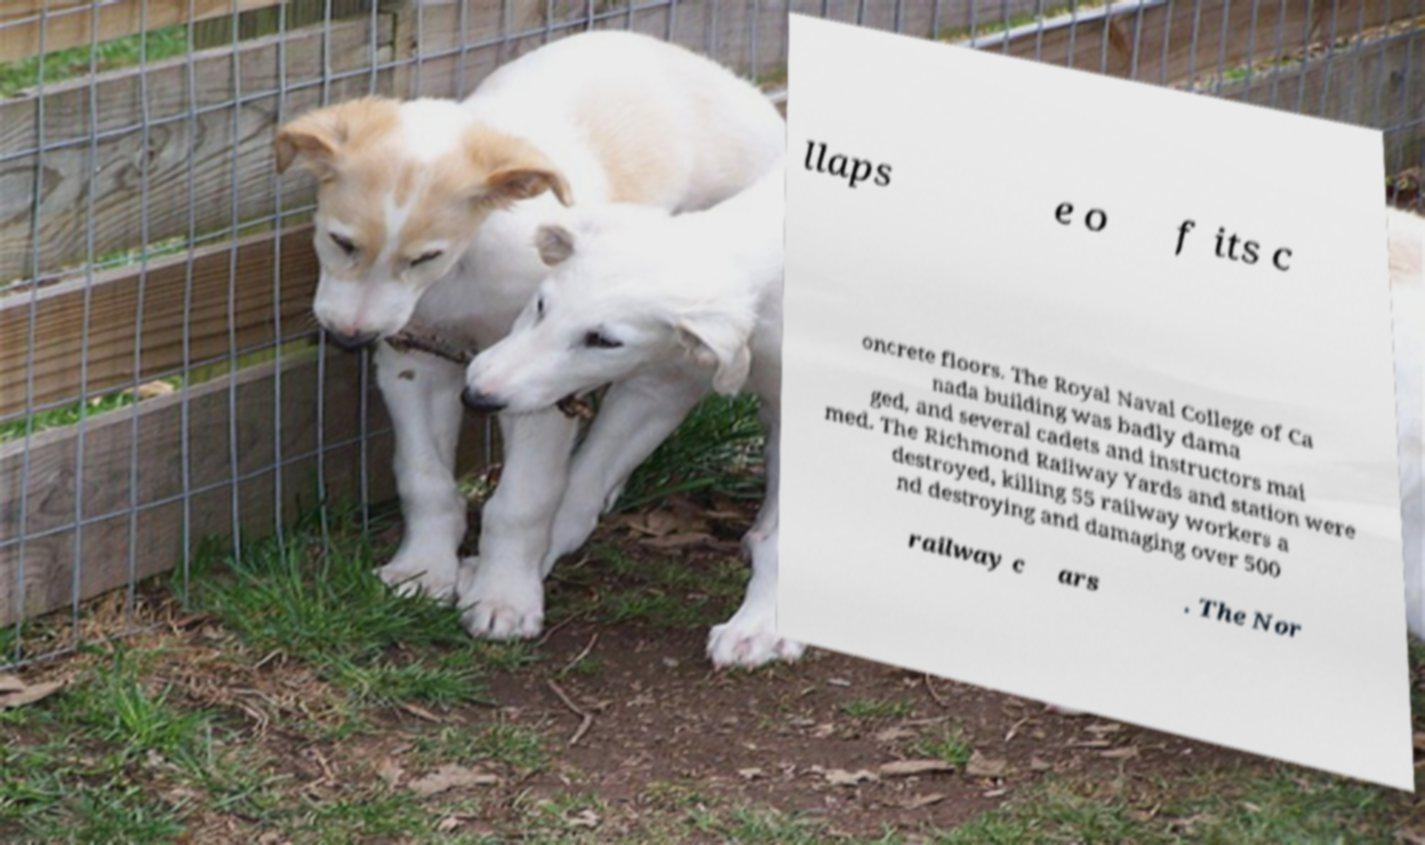What messages or text are displayed in this image? I need them in a readable, typed format. llaps e o f its c oncrete floors. The Royal Naval College of Ca nada building was badly dama ged, and several cadets and instructors mai med. The Richmond Railway Yards and station were destroyed, killing 55 railway workers a nd destroying and damaging over 500 railway c ars . The Nor 